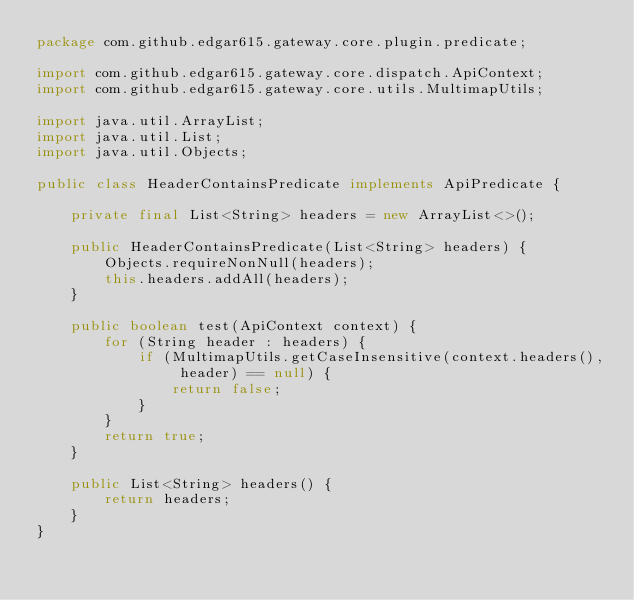<code> <loc_0><loc_0><loc_500><loc_500><_Java_>package com.github.edgar615.gateway.core.plugin.predicate;

import com.github.edgar615.gateway.core.dispatch.ApiContext;
import com.github.edgar615.gateway.core.utils.MultimapUtils;

import java.util.ArrayList;
import java.util.List;
import java.util.Objects;

public class HeaderContainsPredicate implements ApiPredicate {

    private final List<String> headers = new ArrayList<>();

    public HeaderContainsPredicate(List<String> headers) {
        Objects.requireNonNull(headers);
        this.headers.addAll(headers);
    }

    public boolean test(ApiContext context) {
        for (String header : headers) {
            if (MultimapUtils.getCaseInsensitive(context.headers(), header) == null) {
                return false;
            }
        }
        return true;
    }

    public List<String> headers() {
        return headers;
    }
}
</code> 